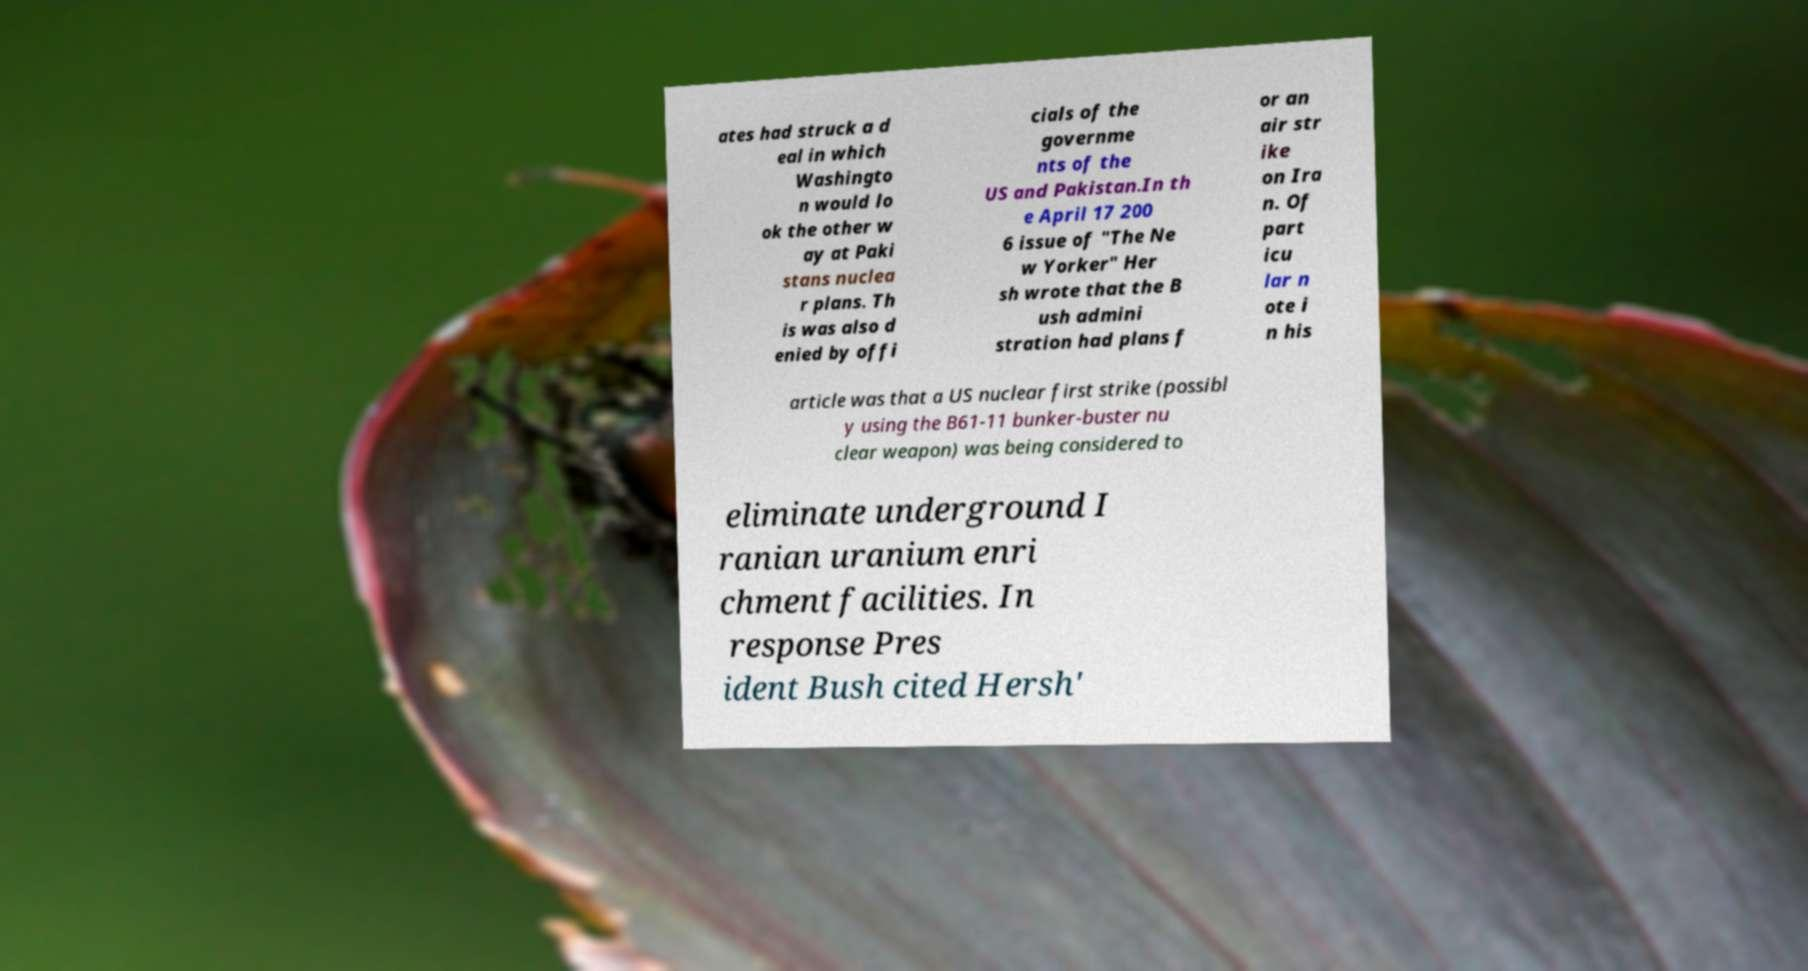What messages or text are displayed in this image? I need them in a readable, typed format. ates had struck a d eal in which Washingto n would lo ok the other w ay at Paki stans nuclea r plans. Th is was also d enied by offi cials of the governme nts of the US and Pakistan.In th e April 17 200 6 issue of "The Ne w Yorker" Her sh wrote that the B ush admini stration had plans f or an air str ike on Ira n. Of part icu lar n ote i n his article was that a US nuclear first strike (possibl y using the B61-11 bunker-buster nu clear weapon) was being considered to eliminate underground I ranian uranium enri chment facilities. In response Pres ident Bush cited Hersh' 